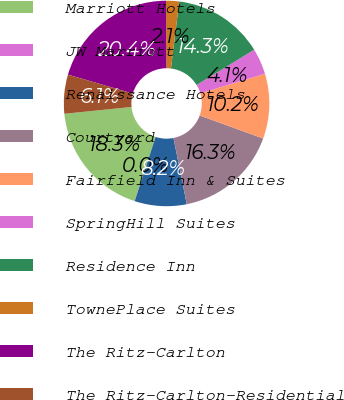Convert chart to OTSL. <chart><loc_0><loc_0><loc_500><loc_500><pie_chart><fcel>Marriott Hotels<fcel>JW Marriott<fcel>Renaissance Hotels<fcel>Courtyard<fcel>Fairfield Inn & Suites<fcel>SpringHill Suites<fcel>Residence Inn<fcel>TownePlace Suites<fcel>The Ritz-Carlton<fcel>The Ritz-Carlton-Residential<nl><fcel>18.34%<fcel>0.03%<fcel>8.17%<fcel>16.31%<fcel>10.2%<fcel>4.1%<fcel>14.27%<fcel>2.06%<fcel>20.38%<fcel>6.13%<nl></chart> 